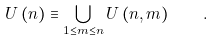<formula> <loc_0><loc_0><loc_500><loc_500>U \left ( n \right ) \equiv \bigcup _ { 1 \leq m \leq n } U \left ( n , m \right ) \quad .</formula> 